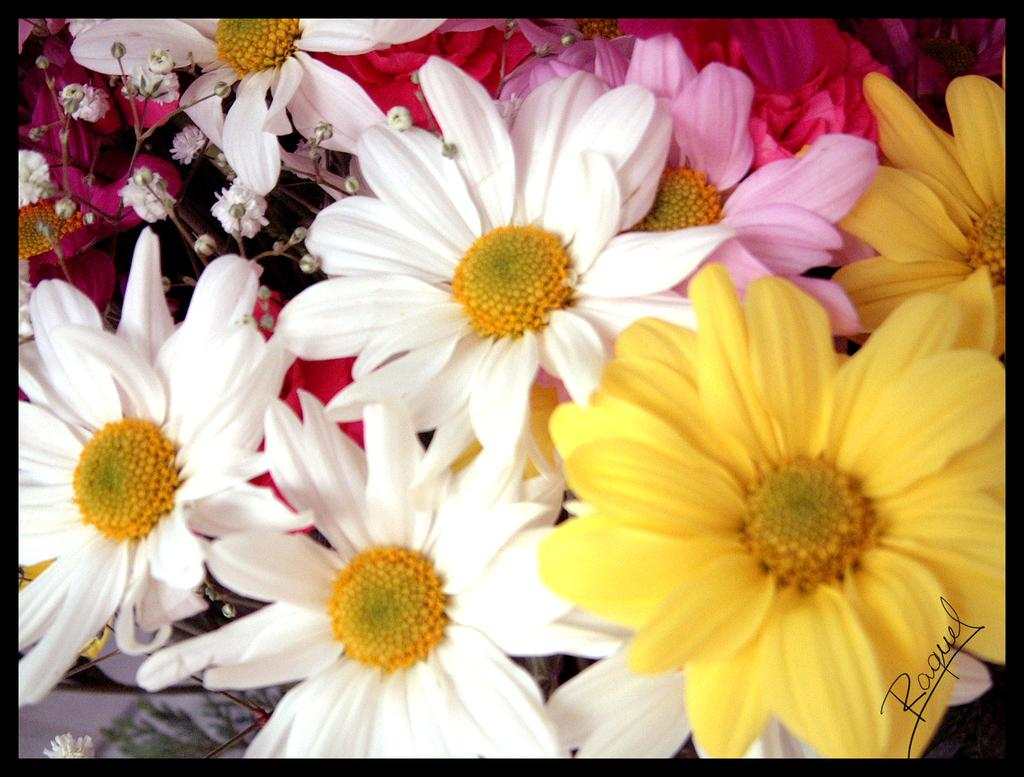What type of living organisms can be seen in the image? Flowers can be seen in the image. How many plates are visible in the image? There are no plates present in the image; it only features flowers. Is there a doll interacting with the flowers in the image? There is no doll present in the image; it only features flowers. 